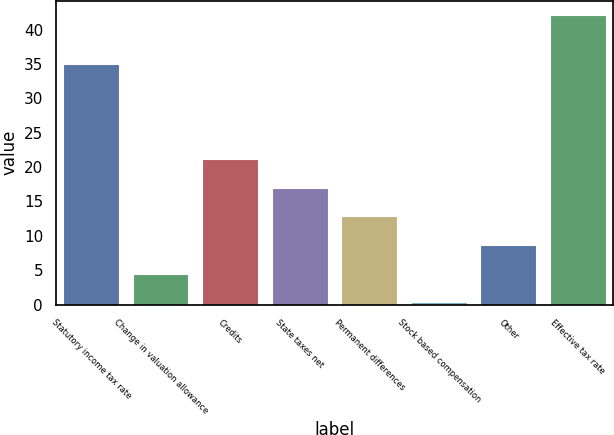<chart> <loc_0><loc_0><loc_500><loc_500><bar_chart><fcel>Statutory income tax rate<fcel>Change in valuation allowance<fcel>Credits<fcel>State taxes net<fcel>Permanent differences<fcel>Stock based compensation<fcel>Other<fcel>Effective tax rate<nl><fcel>35<fcel>4.48<fcel>21.2<fcel>17.02<fcel>12.84<fcel>0.3<fcel>8.66<fcel>42.1<nl></chart> 